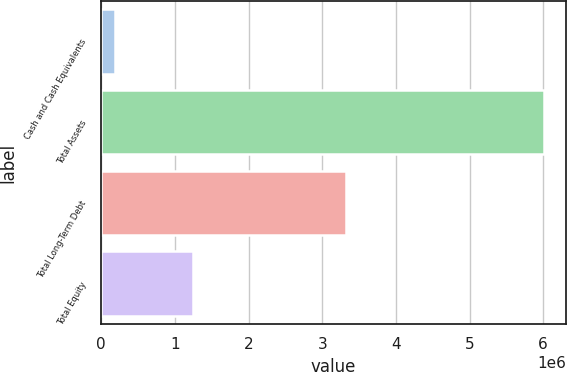Convert chart to OTSL. <chart><loc_0><loc_0><loc_500><loc_500><bar_chart><fcel>Cash and Cash Equivalents<fcel>Total Assets<fcel>Total Long-Term Debt<fcel>Total Equity<nl><fcel>179845<fcel>6.00546e+06<fcel>3.31779e+06<fcel>1.24974e+06<nl></chart> 